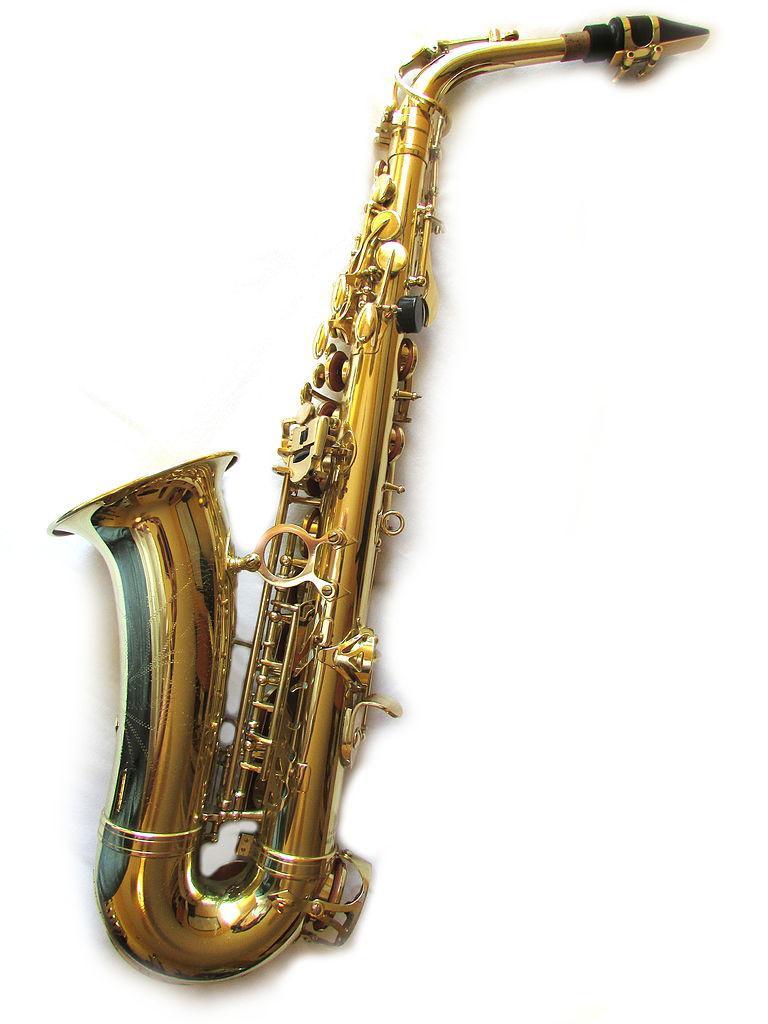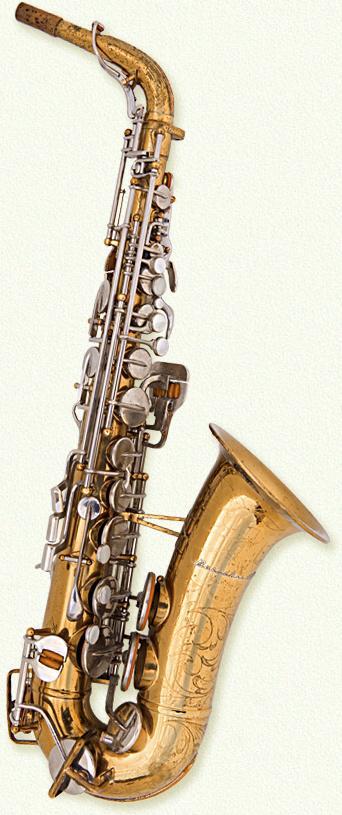The first image is the image on the left, the second image is the image on the right. Assess this claim about the two images: "A word and number are engraved on the saxophone in the image on the right.". Correct or not? Answer yes or no. No. 